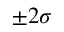Convert formula to latex. <formula><loc_0><loc_0><loc_500><loc_500>\pm 2 \sigma</formula> 